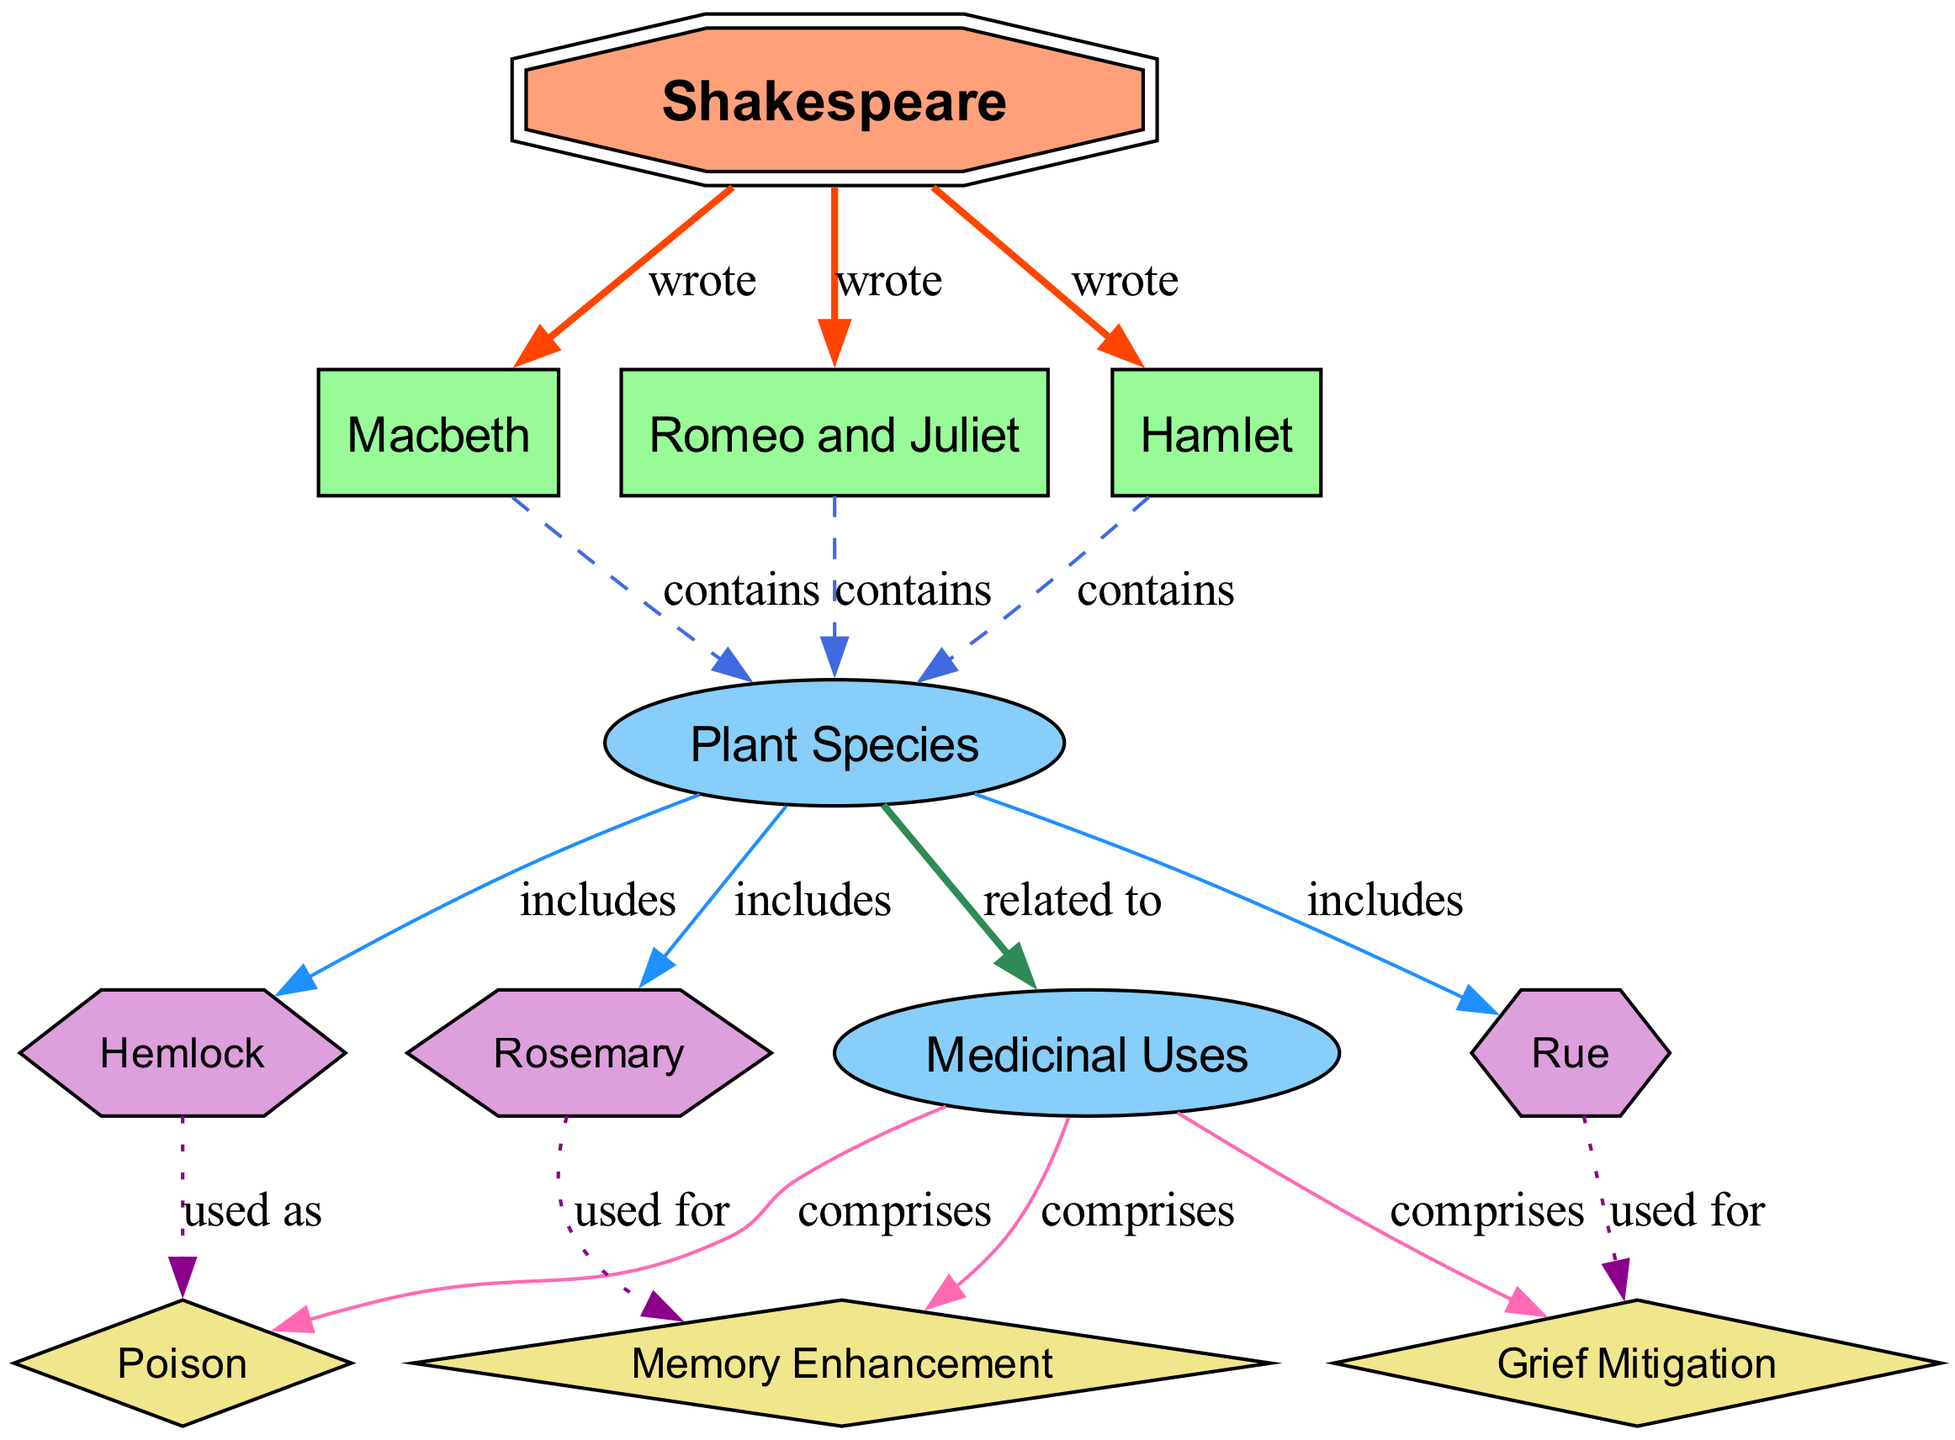What are the three plays attributed to Shakespeare in the diagram? The diagram identifies three plays linked to Shakespeare: Macbeth, Romeo and Juliet, and Hamlet. These are all connected to the author node, indicating their provenance.
Answer: Macbeth, Romeo and Juliet, Hamlet How many plant species are included in the diagram? The diagram includes three specific plant species: Hemlock, Rue, and Rosemary. Each of these plants is connected to the plant species category.
Answer: Three What medicinal use is associated with Hemlock? In the diagram, Hemlock is specifically related to the medicinal use labeled "Poison." This connectivity indicates its application in this context.
Answer: Poison Which plant is tied to the theme of grief mitigation? The diagram shows that Rue is directly associated with "Grief Mitigation." This implies its usage in alleviating grief.
Answer: Rue What is indicated as the medicinal use of Rosemary? The diagram connects Rosemary to "Memory Enhancement," denoting its medicinal application for improving memory.
Answer: Memory Enhancement Which play contains the most connections to plant species? All three plays (Macbeth, Romeo and Juliet, Hamlet) equally connect to plant species, with one connection each. Therefore, none of them contain more connections than the others.
Answer: None How are the relationships between plant species and their uses represented in the diagram? The relationships are indicated through edges that connect plant species to their respective medicinal uses, highlighting how each plant relates to specific applications.
Answer: Through edges What color represents the 'usage' group of edges in the diagram? In the diagram, edges categorized under 'usage' are represented in purple (the color associated with the dotted style).
Answer: Purple How many edges connect Shakespeare to the plays he wrote? The diagram depicts three edges connecting Shakespeare to the three plays he authored, emphasizing his contributions to each.
Answer: Three 